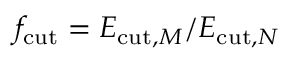Convert formula to latex. <formula><loc_0><loc_0><loc_500><loc_500>f _ { c u t } = E _ { c u t , M } / E _ { c u t , N }</formula> 